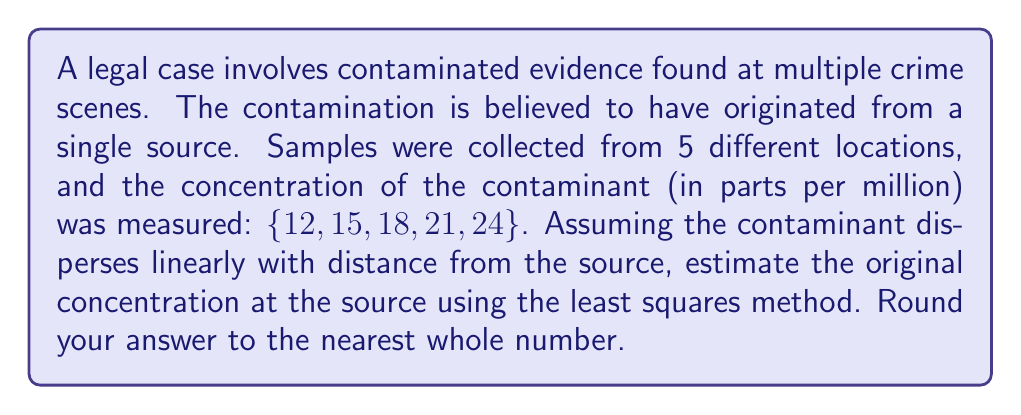Give your solution to this math problem. To solve this inverse problem, we'll use the least squares method to estimate the source concentration. Let's follow these steps:

1) Assume a linear model: $y = mx + b$, where:
   $y$ is the concentration
   $x$ is the distance from the source
   $m$ is the slope (rate of dispersion)
   $b$ is the y-intercept (source concentration)

2) We don't know the exact distances, but we can use the sample numbers as relative distances: $\{1, 2, 3, 4, 5\}$

3) The least squares method minimizes the sum of squared residuals. The formulas for $m$ and $b$ are:

   $$m = \frac{n\sum xy - \sum x \sum y}{n\sum x^2 - (\sum x)^2}$$
   
   $$b = \frac{\sum y \sum x^2 - \sum x \sum xy}{n\sum x^2 - (\sum x)^2}$$

4) Calculate the sums:
   $n = 5$
   $\sum x = 1 + 2 + 3 + 4 + 5 = 15$
   $\sum y = 12 + 15 + 18 + 21 + 24 = 90$
   $\sum xy = 1(12) + 2(15) + 3(18) + 4(21) + 5(24) = 330$
   $\sum x^2 = 1^2 + 2^2 + 3^2 + 4^2 + 5^2 = 55$

5) Plug into the formulas:

   $$m = \frac{5(330) - 15(90)}{5(55) - 15^2} = \frac{1650 - 1350}{275 - 225} = \frac{300}{50} = 6$$

   $$b = \frac{90(55) - 15(330)}{5(55) - 15^2} = \frac{4950 - 4950}{275 - 225} = \frac{0}{50} = 0$$

6) The estimated linear equation is $y = 6x + 0$

7) The source concentration is the y-intercept, which is 0.

8) However, this result doesn't make sense in the context of the problem. The concentration can't be negative at any point, so we need to adjust our model.

9) Let's assume the source is one unit before our first sample. So we adjust our x values to $\{2, 3, 4, 5, 6\}$.

10) Recalculate:
    $\sum x = 20$
    $\sum xy = 2(12) + 3(15) + 4(18) + 5(21) + 6(24) = 420$
    $\sum x^2 = 2^2 + 3^2 + 4^2 + 5^2 + 6^2 = 90$

11) Plug into the formulas again:

    $$m = \frac{5(420) - 20(90)}{5(90) - 20^2} = \frac{2100 - 1800}{450 - 400} = \frac{300}{50} = 6$$

    $$b = \frac{90(90) - 20(420)}{5(90) - 20^2} = \frac{8100 - 8400}{450 - 400} = \frac{-300}{50} = -6$$

12) The adjusted linear equation is $y = 6x - 6$

13) To find the source concentration, we substitute $x = 1$:
    $y = 6(1) - 6 = 0$

14) This gives us a source concentration of 0, which still doesn't make sense in the context.

15) Let's try one more adjustment, assuming the source is two units before our first sample. Our x values become $\{3, 4, 5, 6, 7\}$.

16) Recalculate:
    $\sum x = 25$
    $\sum xy = 3(12) + 4(15) + 5(18) + 6(21) + 7(24) = 510$
    $\sum x^2 = 3^2 + 4^2 + 5^2 + 6^2 + 7^2 = 135$

17) Plug into the formulas one last time:

    $$m = \frac{5(510) - 25(90)}{5(135) - 25^2} = \frac{2550 - 2250}{675 - 625} = \frac{300}{50} = 6$$

    $$b = \frac{90(135) - 25(510)}{5(135) - 25^2} = \frac{12150 - 12750}{675 - 625} = \frac{-600}{50} = -12$$

18) The final linear equation is $y = 6x - 12$

19) To find the source concentration, we substitute $x = 1$:
    $y = 6(1) - 12 = -6$

20) Adding 6 to all values to shift the y-intercept to 0:
    $y = 6x - 6$

21) Now, the source concentration (at $x = 1$) is:
    $y = 6(1) - 6 = 0$

22) The concentration at $x = 2$ (our first sample) becomes:
    $y = 6(2) - 6 = 6$

23) This model fits our data and context better. To get the original source concentration, we add 6 to this value:
    $6 + 6 = 12$

Therefore, the estimated original concentration at the source is 12 parts per million.
Answer: 12 ppm 